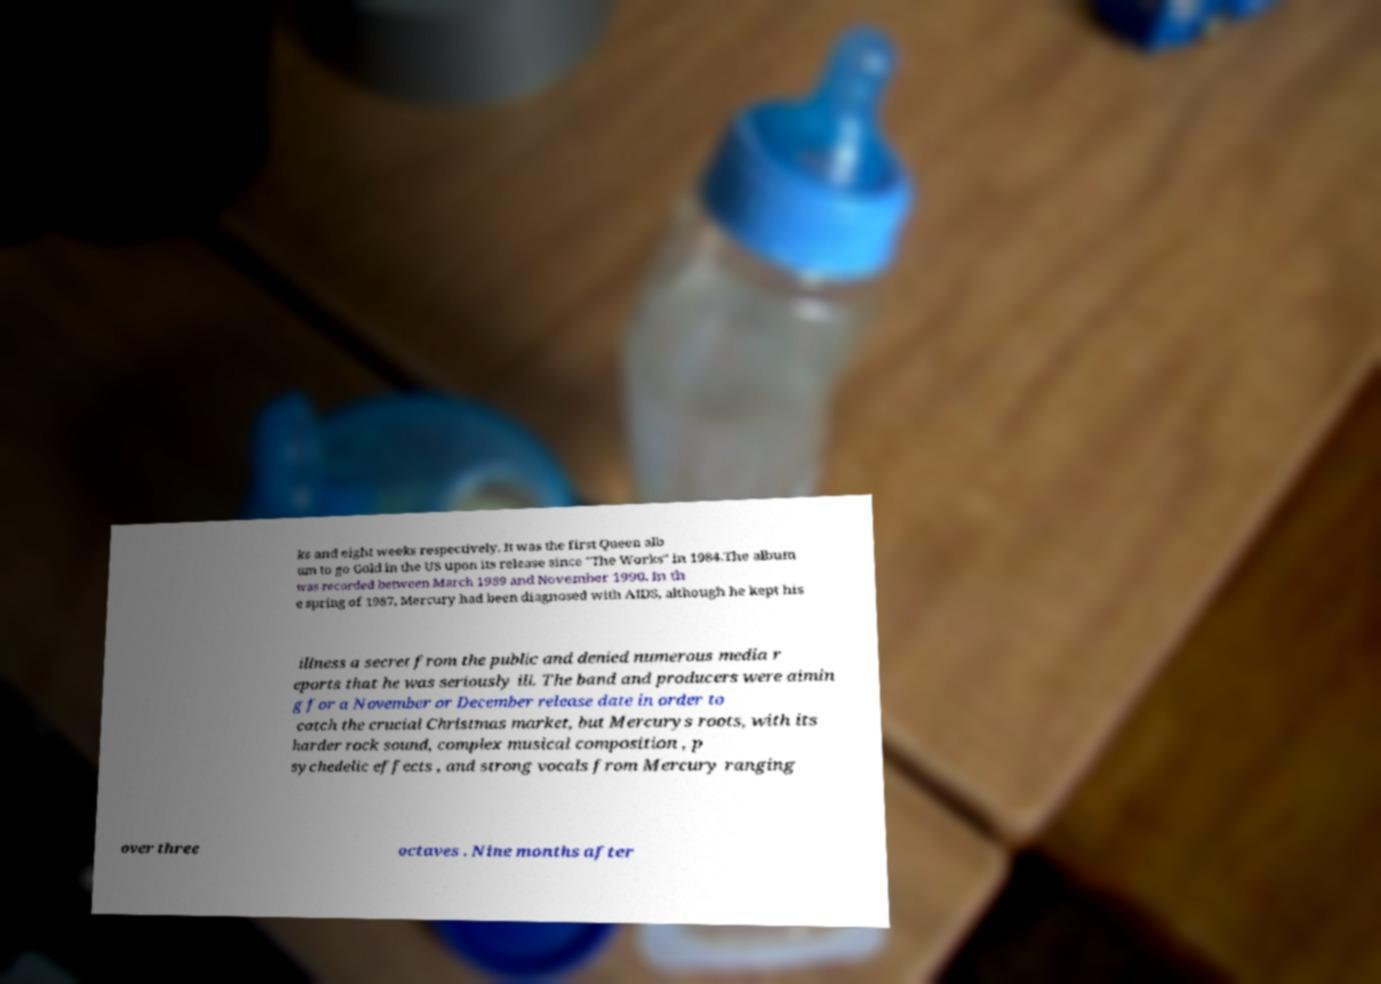For documentation purposes, I need the text within this image transcribed. Could you provide that? ks and eight weeks respectively. It was the first Queen alb um to go Gold in the US upon its release since "The Works" in 1984.The album was recorded between March 1989 and November 1990. In th e spring of 1987, Mercury had been diagnosed with AIDS, although he kept his illness a secret from the public and denied numerous media r eports that he was seriously ill. The band and producers were aimin g for a November or December release date in order to catch the crucial Christmas market, but Mercurys roots, with its harder rock sound, complex musical composition , p sychedelic effects , and strong vocals from Mercury ranging over three octaves . Nine months after 